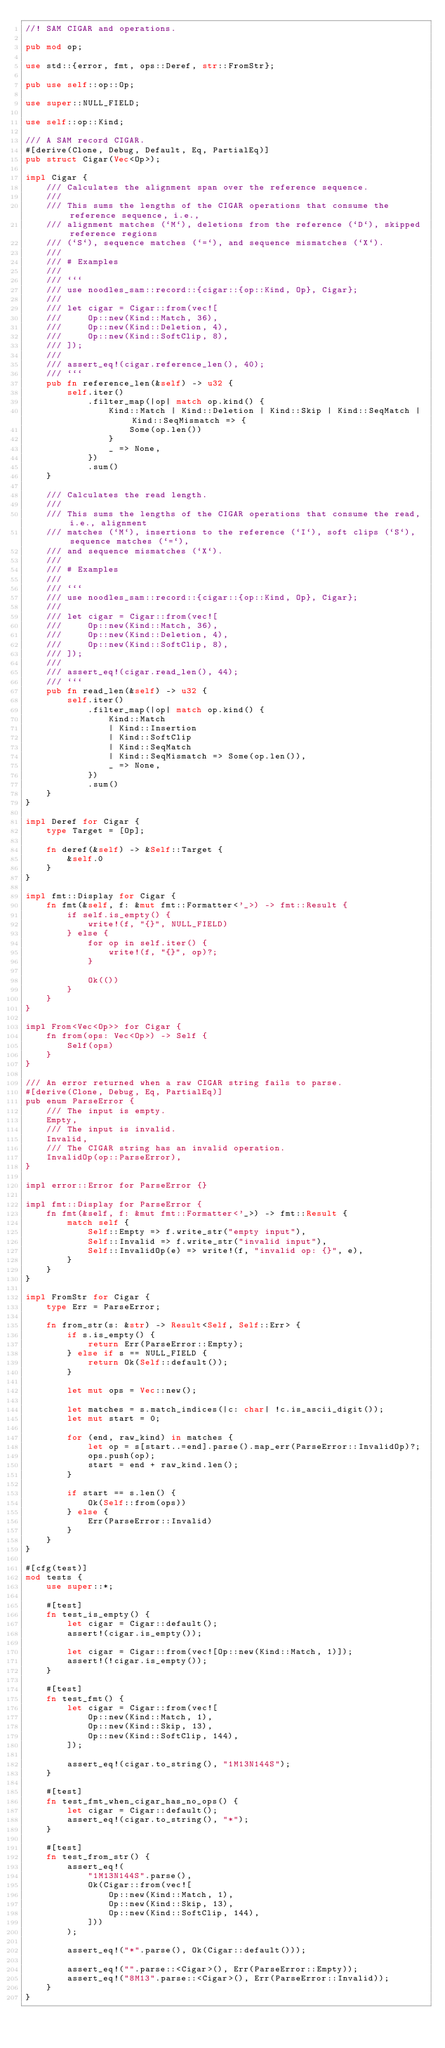<code> <loc_0><loc_0><loc_500><loc_500><_Rust_>//! SAM CIGAR and operations.

pub mod op;

use std::{error, fmt, ops::Deref, str::FromStr};

pub use self::op::Op;

use super::NULL_FIELD;

use self::op::Kind;

/// A SAM record CIGAR.
#[derive(Clone, Debug, Default, Eq, PartialEq)]
pub struct Cigar(Vec<Op>);

impl Cigar {
    /// Calculates the alignment span over the reference sequence.
    ///
    /// This sums the lengths of the CIGAR operations that consume the reference sequence, i.e.,
    /// alignment matches (`M`), deletions from the reference (`D`), skipped reference regions
    /// (`S`), sequence matches (`=`), and sequence mismatches (`X`).
    ///
    /// # Examples
    ///
    /// ```
    /// use noodles_sam::record::{cigar::{op::Kind, Op}, Cigar};
    ///
    /// let cigar = Cigar::from(vec![
    ///     Op::new(Kind::Match, 36),
    ///     Op::new(Kind::Deletion, 4),
    ///     Op::new(Kind::SoftClip, 8),
    /// ]);
    ///
    /// assert_eq!(cigar.reference_len(), 40);
    /// ```
    pub fn reference_len(&self) -> u32 {
        self.iter()
            .filter_map(|op| match op.kind() {
                Kind::Match | Kind::Deletion | Kind::Skip | Kind::SeqMatch | Kind::SeqMismatch => {
                    Some(op.len())
                }
                _ => None,
            })
            .sum()
    }

    /// Calculates the read length.
    ///
    /// This sums the lengths of the CIGAR operations that consume the read, i.e., alignment
    /// matches (`M`), insertions to the reference (`I`), soft clips (`S`), sequence matches (`=`),
    /// and sequence mismatches (`X`).
    ///
    /// # Examples
    ///
    /// ```
    /// use noodles_sam::record::{cigar::{op::Kind, Op}, Cigar};
    ///
    /// let cigar = Cigar::from(vec![
    ///     Op::new(Kind::Match, 36),
    ///     Op::new(Kind::Deletion, 4),
    ///     Op::new(Kind::SoftClip, 8),
    /// ]);
    ///
    /// assert_eq!(cigar.read_len(), 44);
    /// ```
    pub fn read_len(&self) -> u32 {
        self.iter()
            .filter_map(|op| match op.kind() {
                Kind::Match
                | Kind::Insertion
                | Kind::SoftClip
                | Kind::SeqMatch
                | Kind::SeqMismatch => Some(op.len()),
                _ => None,
            })
            .sum()
    }
}

impl Deref for Cigar {
    type Target = [Op];

    fn deref(&self) -> &Self::Target {
        &self.0
    }
}

impl fmt::Display for Cigar {
    fn fmt(&self, f: &mut fmt::Formatter<'_>) -> fmt::Result {
        if self.is_empty() {
            write!(f, "{}", NULL_FIELD)
        } else {
            for op in self.iter() {
                write!(f, "{}", op)?;
            }

            Ok(())
        }
    }
}

impl From<Vec<Op>> for Cigar {
    fn from(ops: Vec<Op>) -> Self {
        Self(ops)
    }
}

/// An error returned when a raw CIGAR string fails to parse.
#[derive(Clone, Debug, Eq, PartialEq)]
pub enum ParseError {
    /// The input is empty.
    Empty,
    /// The input is invalid.
    Invalid,
    /// The CIGAR string has an invalid operation.
    InvalidOp(op::ParseError),
}

impl error::Error for ParseError {}

impl fmt::Display for ParseError {
    fn fmt(&self, f: &mut fmt::Formatter<'_>) -> fmt::Result {
        match self {
            Self::Empty => f.write_str("empty input"),
            Self::Invalid => f.write_str("invalid input"),
            Self::InvalidOp(e) => write!(f, "invalid op: {}", e),
        }
    }
}

impl FromStr for Cigar {
    type Err = ParseError;

    fn from_str(s: &str) -> Result<Self, Self::Err> {
        if s.is_empty() {
            return Err(ParseError::Empty);
        } else if s == NULL_FIELD {
            return Ok(Self::default());
        }

        let mut ops = Vec::new();

        let matches = s.match_indices(|c: char| !c.is_ascii_digit());
        let mut start = 0;

        for (end, raw_kind) in matches {
            let op = s[start..=end].parse().map_err(ParseError::InvalidOp)?;
            ops.push(op);
            start = end + raw_kind.len();
        }

        if start == s.len() {
            Ok(Self::from(ops))
        } else {
            Err(ParseError::Invalid)
        }
    }
}

#[cfg(test)]
mod tests {
    use super::*;

    #[test]
    fn test_is_empty() {
        let cigar = Cigar::default();
        assert!(cigar.is_empty());

        let cigar = Cigar::from(vec![Op::new(Kind::Match, 1)]);
        assert!(!cigar.is_empty());
    }

    #[test]
    fn test_fmt() {
        let cigar = Cigar::from(vec![
            Op::new(Kind::Match, 1),
            Op::new(Kind::Skip, 13),
            Op::new(Kind::SoftClip, 144),
        ]);

        assert_eq!(cigar.to_string(), "1M13N144S");
    }

    #[test]
    fn test_fmt_when_cigar_has_no_ops() {
        let cigar = Cigar::default();
        assert_eq!(cigar.to_string(), "*");
    }

    #[test]
    fn test_from_str() {
        assert_eq!(
            "1M13N144S".parse(),
            Ok(Cigar::from(vec![
                Op::new(Kind::Match, 1),
                Op::new(Kind::Skip, 13),
                Op::new(Kind::SoftClip, 144),
            ]))
        );

        assert_eq!("*".parse(), Ok(Cigar::default()));

        assert_eq!("".parse::<Cigar>(), Err(ParseError::Empty));
        assert_eq!("8M13".parse::<Cigar>(), Err(ParseError::Invalid));
    }
}
</code> 